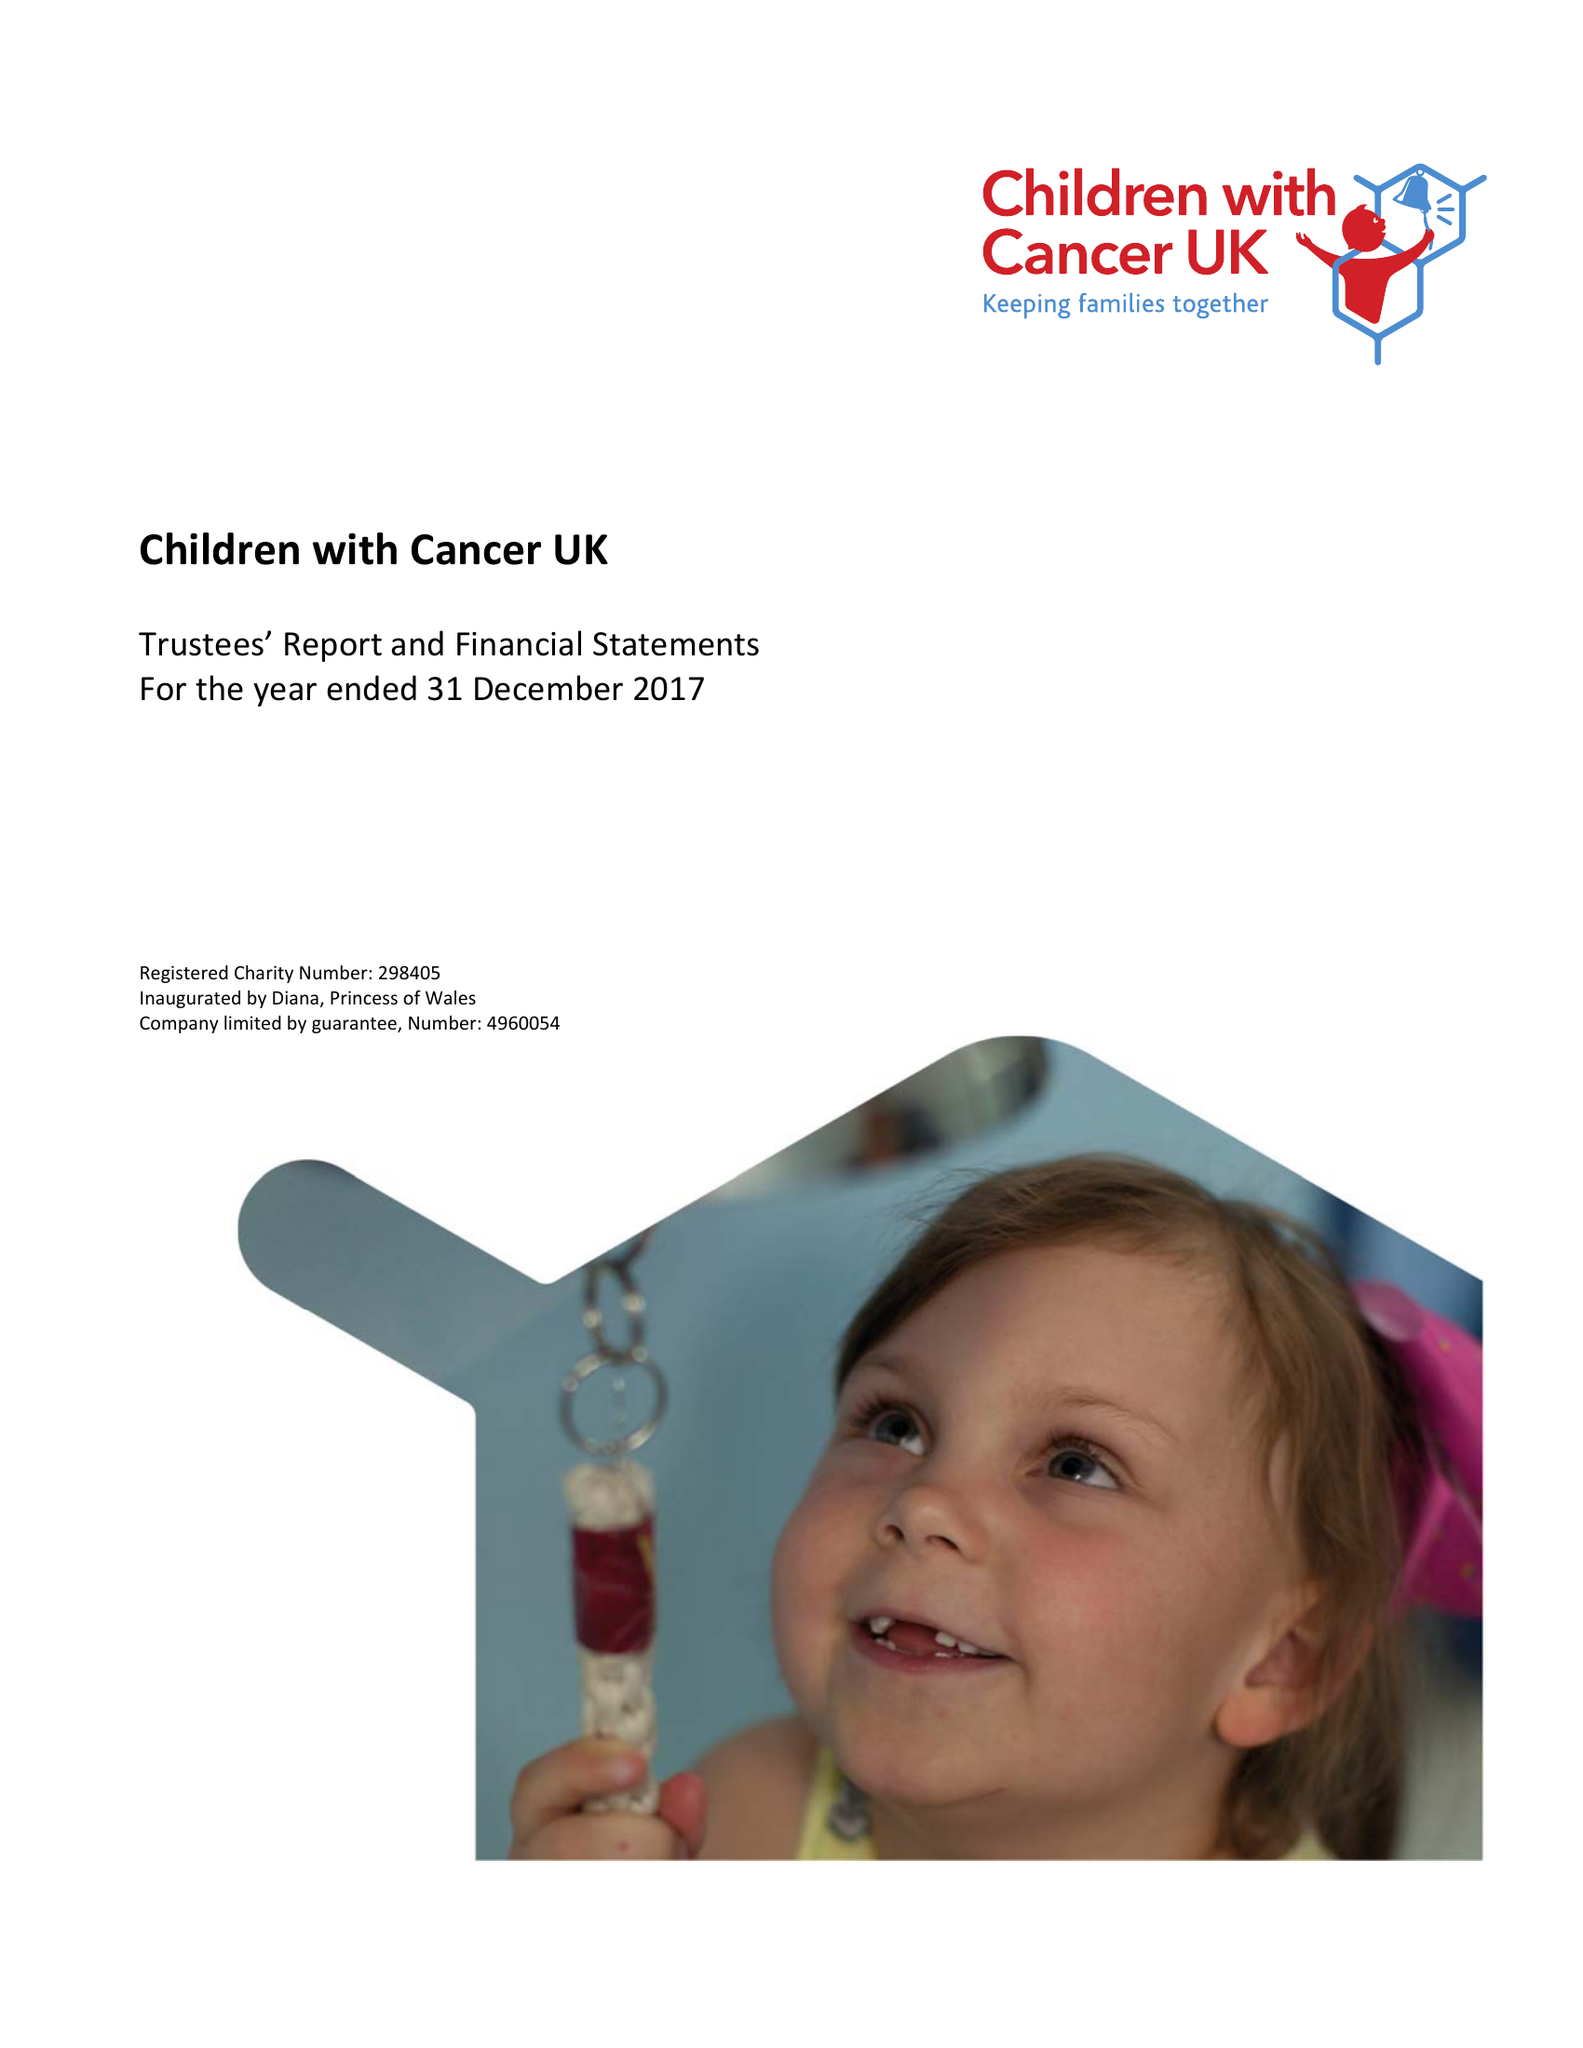What is the value for the address__postcode?
Answer the question using a single word or phrase. WC1N 3JQ 